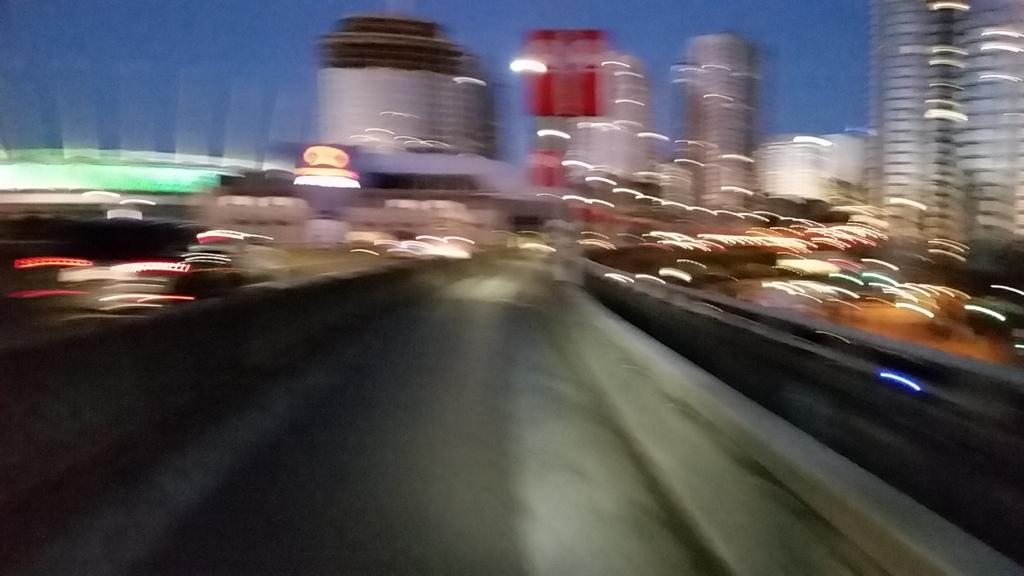What is the main feature of the image? There is a road in the image. What else can be seen in the image besides the road? There are buildings and vehicles in the image. What is visible in the sky in the image? The sky is visible in the image. Is there any regret visible in the image? There is no indication of regret in the image. Can you tell me how the organization is structured in the image? There is no organization present in the image; it features a road, buildings, and vehicles. 